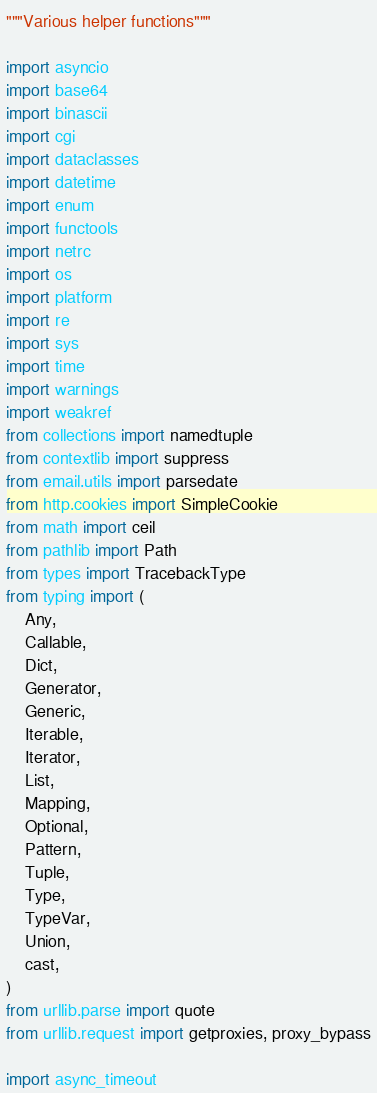Convert code to text. <code><loc_0><loc_0><loc_500><loc_500><_Python_>"""Various helper functions"""

import asyncio
import base64
import binascii
import cgi
import dataclasses
import datetime
import enum
import functools
import netrc
import os
import platform
import re
import sys
import time
import warnings
import weakref
from collections import namedtuple
from contextlib import suppress
from email.utils import parsedate
from http.cookies import SimpleCookie
from math import ceil
from pathlib import Path
from types import TracebackType
from typing import (
    Any,
    Callable,
    Dict,
    Generator,
    Generic,
    Iterable,
    Iterator,
    List,
    Mapping,
    Optional,
    Pattern,
    Tuple,
    Type,
    TypeVar,
    Union,
    cast,
)
from urllib.parse import quote
from urllib.request import getproxies, proxy_bypass

import async_timeout</code> 